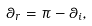Convert formula to latex. <formula><loc_0><loc_0><loc_500><loc_500>\theta _ { r } = \pi - \theta _ { i } ,</formula> 